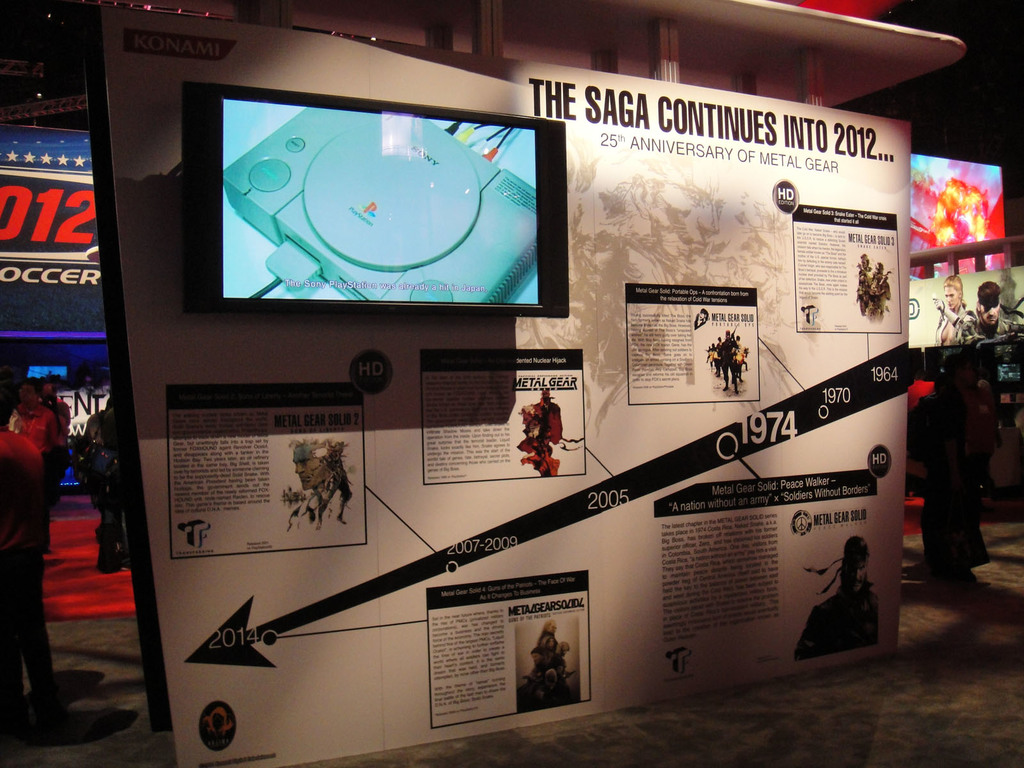Provide a one-sentence caption for the provided image. A detailed exhibit illustrating the 25-year history of the Metal Gear series, highlighting key releases like Metal Gear Solid 2 and milestones from 1987 through 2012. 